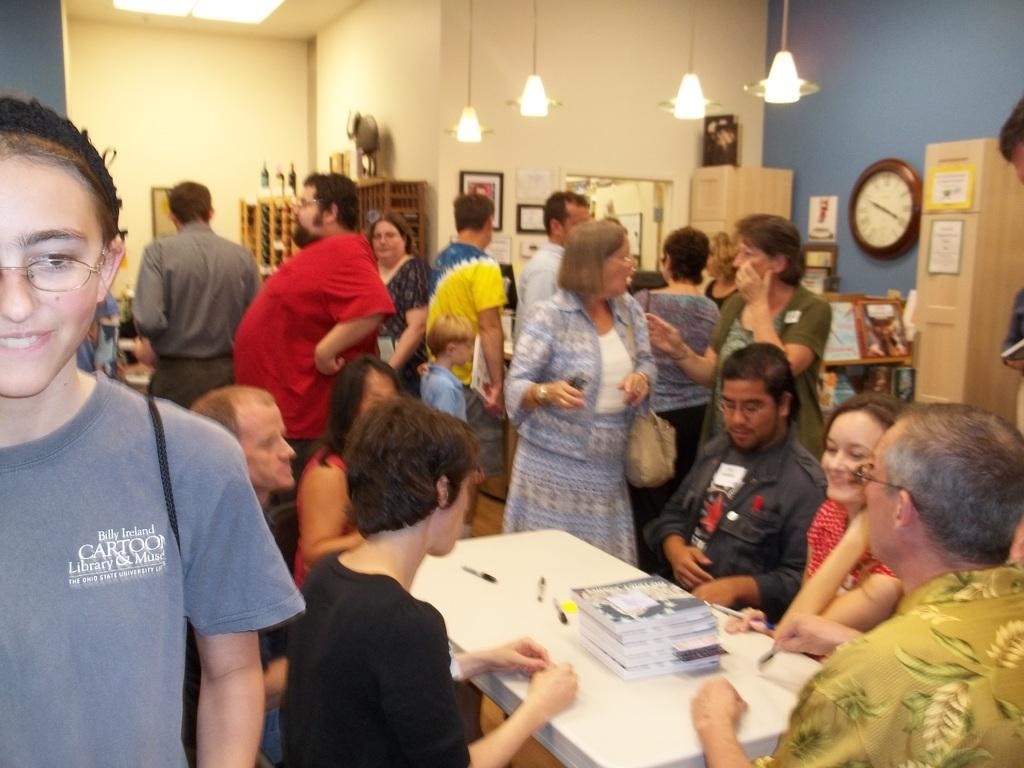What are the people in the image doing? Some people are standing, and others are sitting in the image. What objects can be seen on the table in the image? There are books on the table in the image. What is hanging on the wall in the image? There is a clock and photo frames on the wall in the image. What type of lighting is present in the image? There are lights in the image. What type of waste can be seen on the floor in the image? There is no waste visible on the floor in the image. What nut is being cracked by the person in the image? There is no nut or person cracking a nut present in the image. 